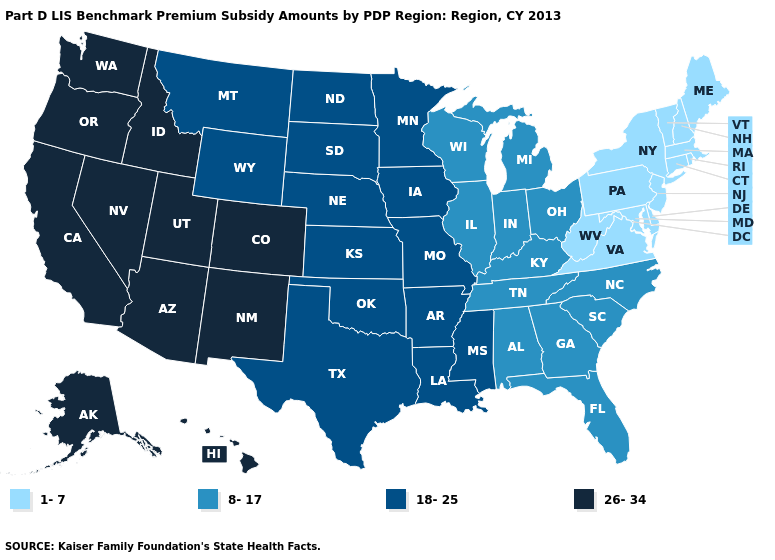Name the states that have a value in the range 26-34?
Concise answer only. Alaska, Arizona, California, Colorado, Hawaii, Idaho, Nevada, New Mexico, Oregon, Utah, Washington. What is the lowest value in the South?
Short answer required. 1-7. Name the states that have a value in the range 26-34?
Short answer required. Alaska, Arizona, California, Colorado, Hawaii, Idaho, Nevada, New Mexico, Oregon, Utah, Washington. Which states hav the highest value in the Northeast?
Answer briefly. Connecticut, Maine, Massachusetts, New Hampshire, New Jersey, New York, Pennsylvania, Rhode Island, Vermont. Does Maine have a lower value than Delaware?
Answer briefly. No. What is the value of Texas?
Keep it brief. 18-25. What is the value of South Carolina?
Answer briefly. 8-17. What is the value of West Virginia?
Quick response, please. 1-7. What is the value of Florida?
Give a very brief answer. 8-17. Which states hav the highest value in the Northeast?
Answer briefly. Connecticut, Maine, Massachusetts, New Hampshire, New Jersey, New York, Pennsylvania, Rhode Island, Vermont. What is the value of Ohio?
Answer briefly. 8-17. Among the states that border Alabama , does Georgia have the lowest value?
Keep it brief. Yes. What is the value of Iowa?
Quick response, please. 18-25. Name the states that have a value in the range 18-25?
Quick response, please. Arkansas, Iowa, Kansas, Louisiana, Minnesota, Mississippi, Missouri, Montana, Nebraska, North Dakota, Oklahoma, South Dakota, Texas, Wyoming. 